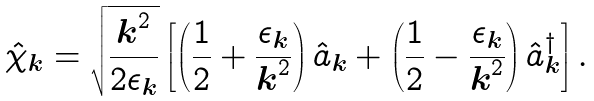<formula> <loc_0><loc_0><loc_500><loc_500>\hat { \chi } _ { \boldsymbol k } = \sqrt { \frac { { \boldsymbol k } ^ { 2 } } { 2 \epsilon _ { \boldsymbol k } } } \left [ \left ( \frac { 1 } { 2 } + \frac { \epsilon _ { \boldsymbol k } } { { \boldsymbol k } ^ { 2 } } \right ) \hat { a } _ { \boldsymbol k } + \left ( \frac { 1 } { 2 } - \frac { \epsilon _ { \boldsymbol k } } { { \boldsymbol k } ^ { 2 } } \right ) \hat { a } _ { \boldsymbol k } ^ { \dagger } \right ] .</formula> 